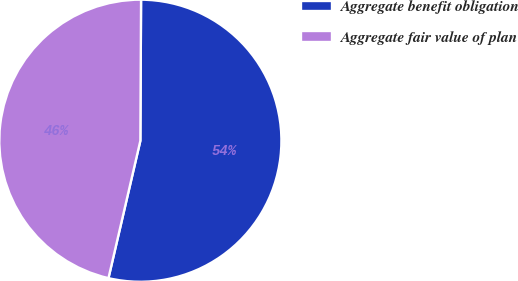<chart> <loc_0><loc_0><loc_500><loc_500><pie_chart><fcel>Aggregate benefit obligation<fcel>Aggregate fair value of plan<nl><fcel>53.55%<fcel>46.45%<nl></chart> 